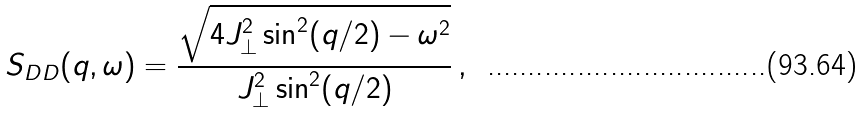<formula> <loc_0><loc_0><loc_500><loc_500>S _ { D D } ( q , \omega ) = \frac { \sqrt { 4 J _ { \perp } ^ { 2 } \sin ^ { 2 } ( q / 2 ) - \omega ^ { 2 } } } { J _ { \perp } ^ { 2 } \sin ^ { 2 } ( q / 2 ) } \, ,</formula> 